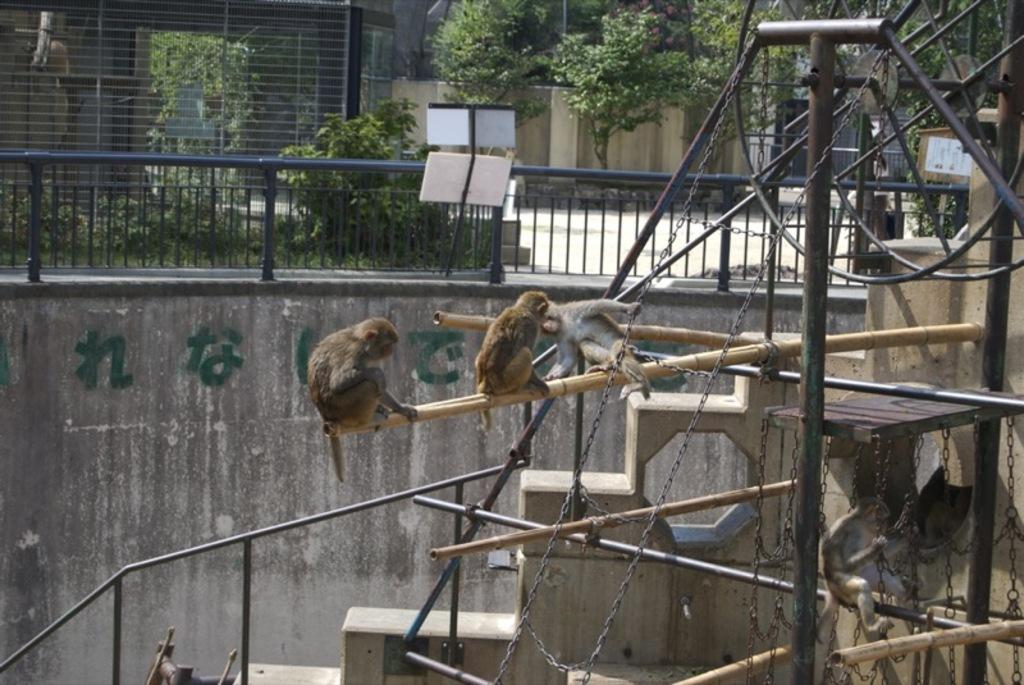What type of animals can be seen in the image? There are monkeys in the image. What objects are present in the image that could be used for support or balance? There are wooden sticks, steps, poles, and railing in the image. What type of structures are visible in the image? There are walls and a grille in the image. What natural elements can be seen in the image? There are plants, trees, and a grille in the image. What other objects can be seen in the image? There are chains and other objects in the image. What type of humor can be seen in the image? There is no humor present in the image; it is a scene featuring monkeys and various objects and structures. 